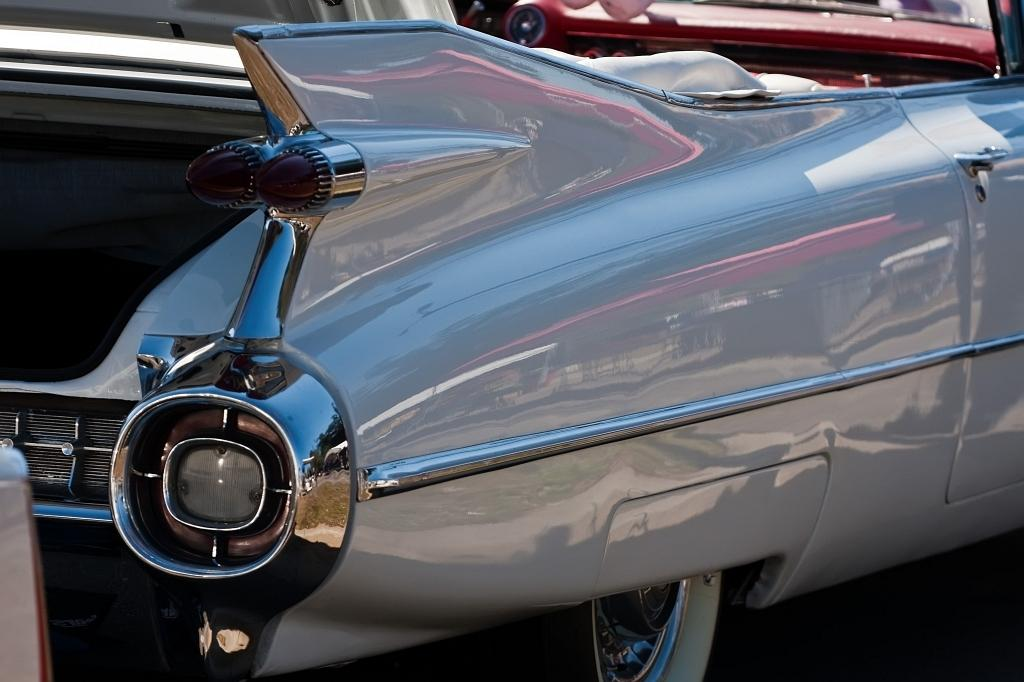What can be seen in the image? There are vehicles and reflections of objects on a grey object in the image. Can you describe the vehicles in the image? The provided facts do not give specific details about the vehicles, so we cannot describe them further. What is the grey object with reflections on it? The facts do not specify what the grey object is, so we cannot identify it. How many mittens are visible in the image? There are no mittens present in the image. What is the existence of the net in the image? There is no mention of a net in the provided facts, so we cannot determine its existence in the image. 